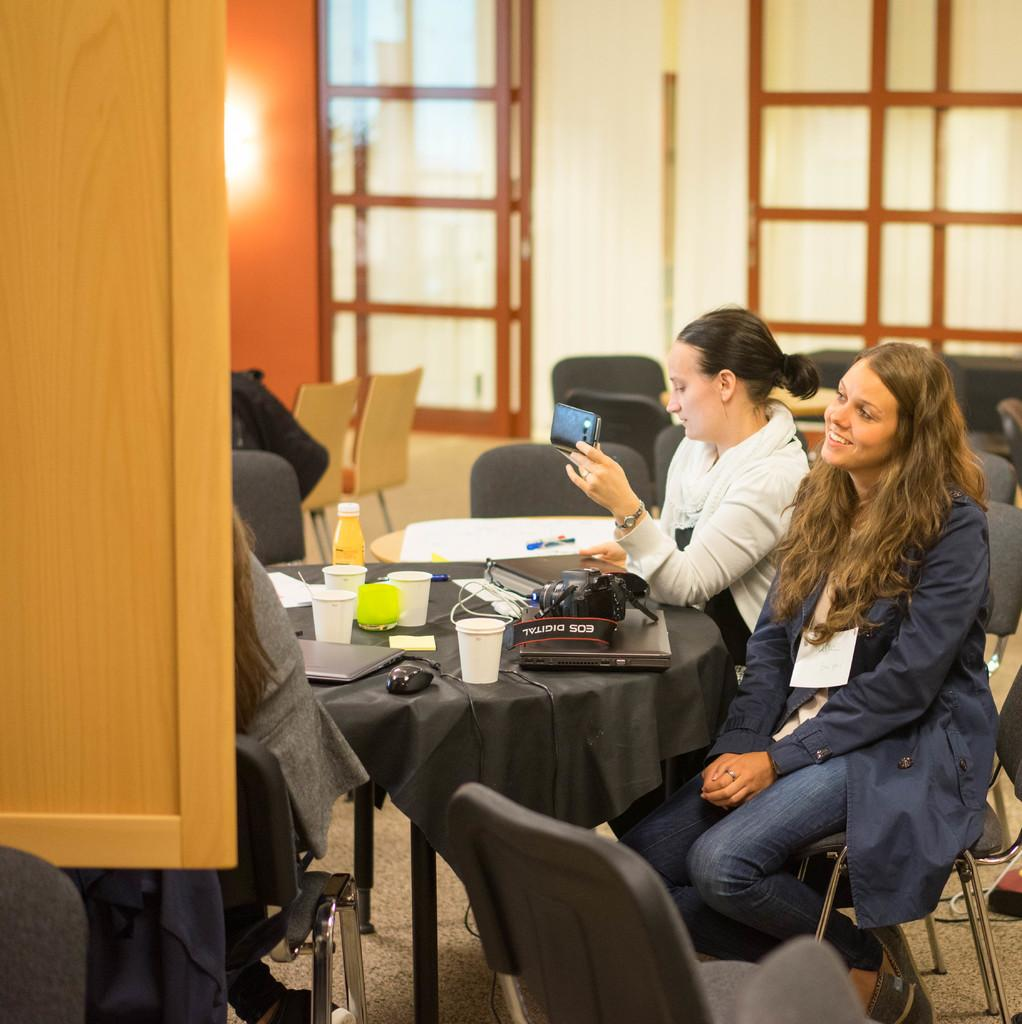What are the people in the image doing? People are sitting on chairs across a table in the image. What objects can be seen on the table? There are glasses, a laptop, a mouse, a bottle, paper, and a pen on the table. What is the person at the back holding? The person at the back is holding a phone in her hand. What type of eggs can be seen in the image? There are no eggs present in the image. Is there a tank visible in the image? There is no tank present in the image. 